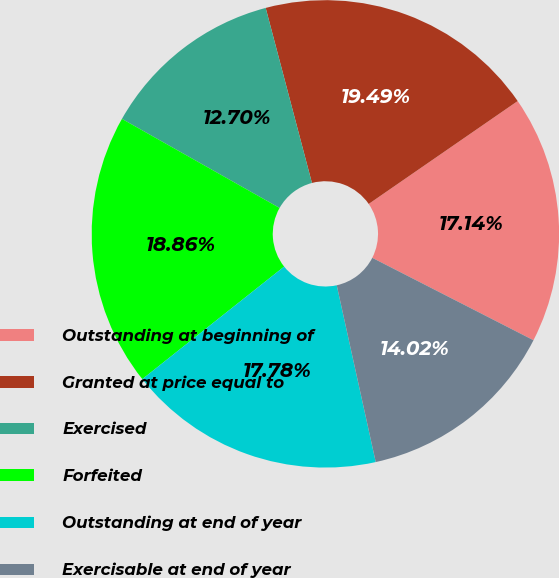Convert chart. <chart><loc_0><loc_0><loc_500><loc_500><pie_chart><fcel>Outstanding at beginning of<fcel>Granted at price equal to<fcel>Exercised<fcel>Forfeited<fcel>Outstanding at end of year<fcel>Exercisable at end of year<nl><fcel>17.14%<fcel>19.49%<fcel>12.7%<fcel>18.86%<fcel>17.78%<fcel>14.02%<nl></chart> 